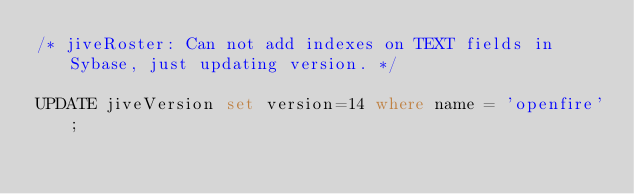<code> <loc_0><loc_0><loc_500><loc_500><_SQL_>/* jiveRoster: Can not add indexes on TEXT fields in Sybase, just updating version. */

UPDATE jiveVersion set version=14 where name = 'openfire';
</code> 